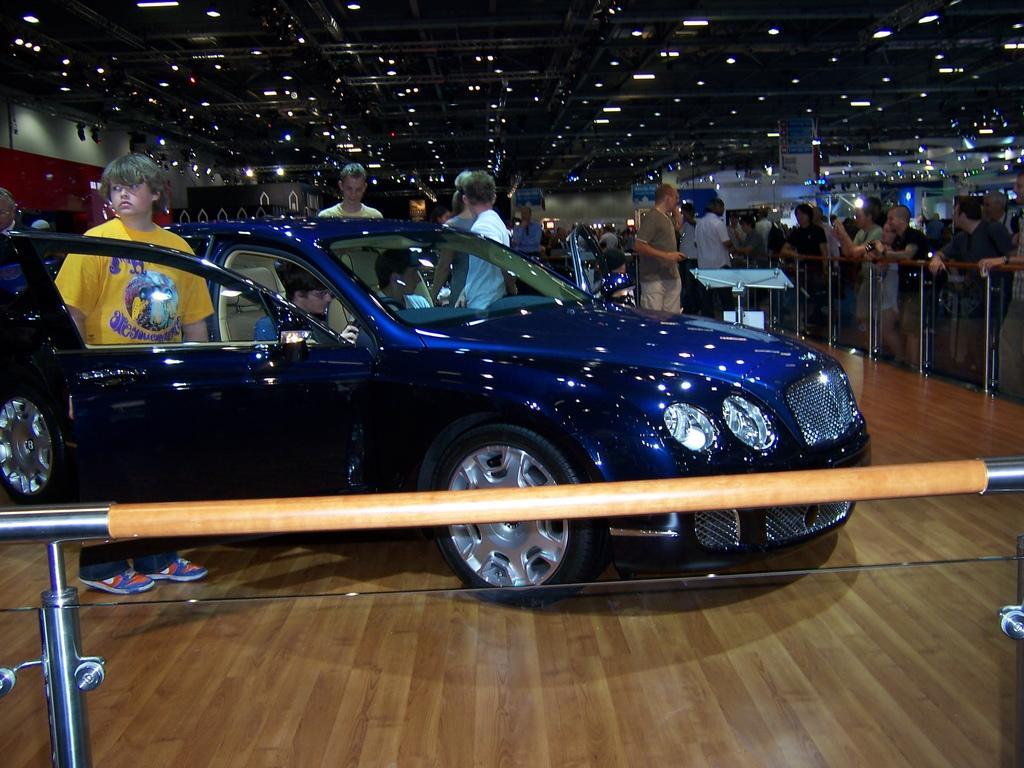How would you summarize this image in a sentence or two? In this picture I can see a blue color car on the floor and in the car I can see some people sitting in it. In the background I can see group of people standing. Here I can see fence. I can also see lights on the ceiling. On the left side I can see a wall. 